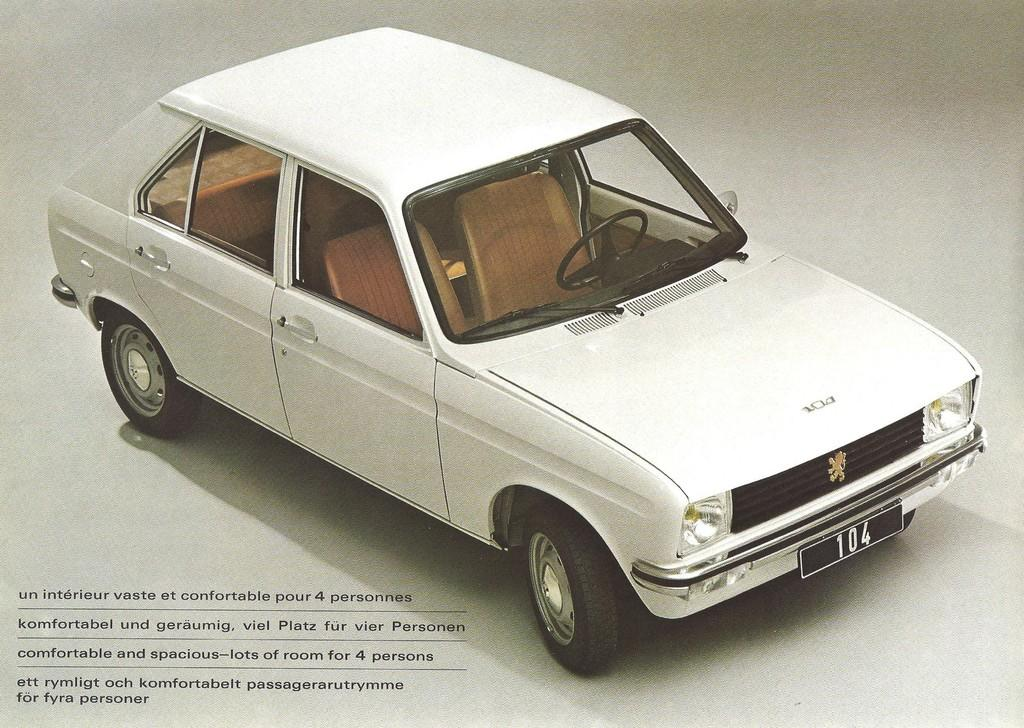What is the main subject of the image? There is a car in the image. Can you describe the color of the car? The car is white. Is there any text present in the image? Yes, there is some text at the bottom of the image. What type of rhythm can be heard coming from the car in the image? There is no sound or rhythm associated with the car in the image, as it is a still photograph. 